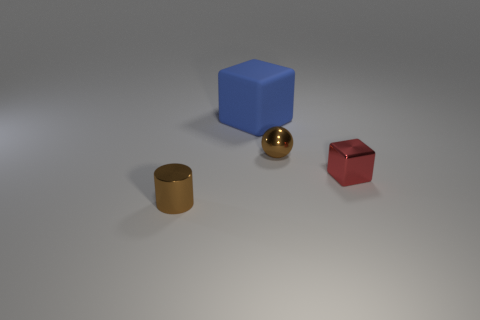Add 3 small objects. How many objects exist? 7 Subtract all cylinders. How many objects are left? 3 Subtract 1 balls. How many balls are left? 0 Subtract all yellow spheres. How many blue cubes are left? 1 Subtract all brown rubber cylinders. Subtract all tiny shiny cylinders. How many objects are left? 3 Add 3 red blocks. How many red blocks are left? 4 Add 2 brown shiny things. How many brown shiny things exist? 4 Subtract all red cubes. How many cubes are left? 1 Subtract 0 yellow spheres. How many objects are left? 4 Subtract all yellow blocks. Subtract all brown cylinders. How many blocks are left? 2 